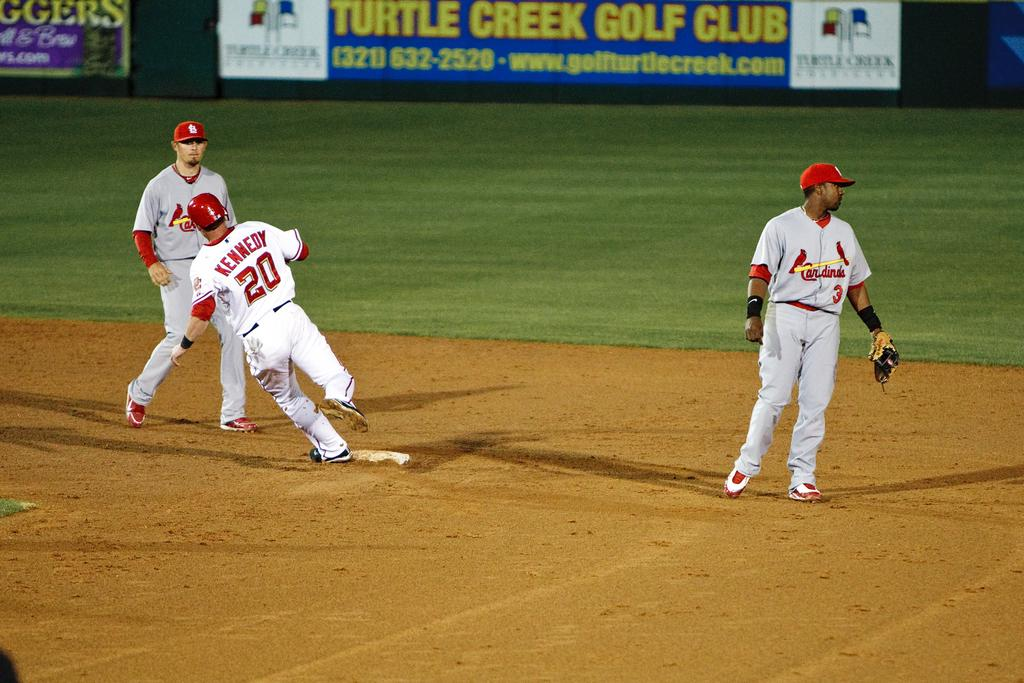Provide a one-sentence caption for the provided image. Three baseball players are in the middle of a game on a field bearing an advertisement for Turtle Creek Golf Club. 